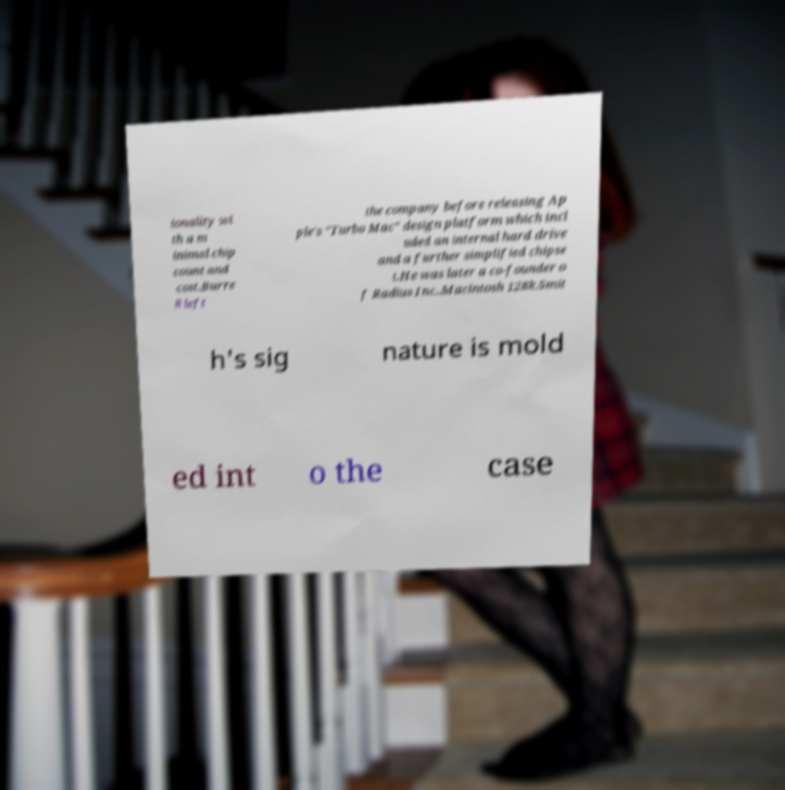Please identify and transcribe the text found in this image. ionality wi th a m inimal chip count and cost.Burre ll left the company before releasing Ap ple's "Turbo Mac" design platform which incl uded an internal hard drive and a further simplified chipse t.He was later a co-founder o f Radius Inc..Macintosh 128k.Smit h's sig nature is mold ed int o the case 